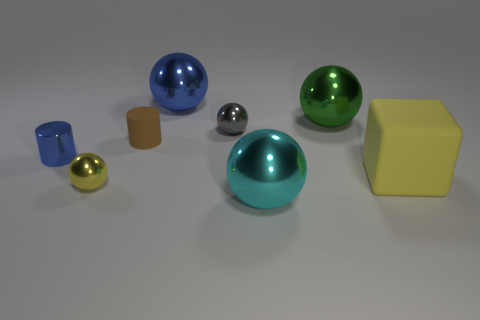Subtract 2 spheres. How many spheres are left? 3 Subtract all yellow balls. How many balls are left? 4 Subtract all blue shiny balls. How many balls are left? 4 Subtract all purple balls. Subtract all blue cylinders. How many balls are left? 5 Add 1 large rubber cubes. How many objects exist? 9 Subtract all blocks. How many objects are left? 7 Add 4 tiny cyan spheres. How many tiny cyan spheres exist? 4 Subtract 0 brown balls. How many objects are left? 8 Subtract all big green metallic balls. Subtract all small gray matte balls. How many objects are left? 7 Add 8 cyan balls. How many cyan balls are left? 9 